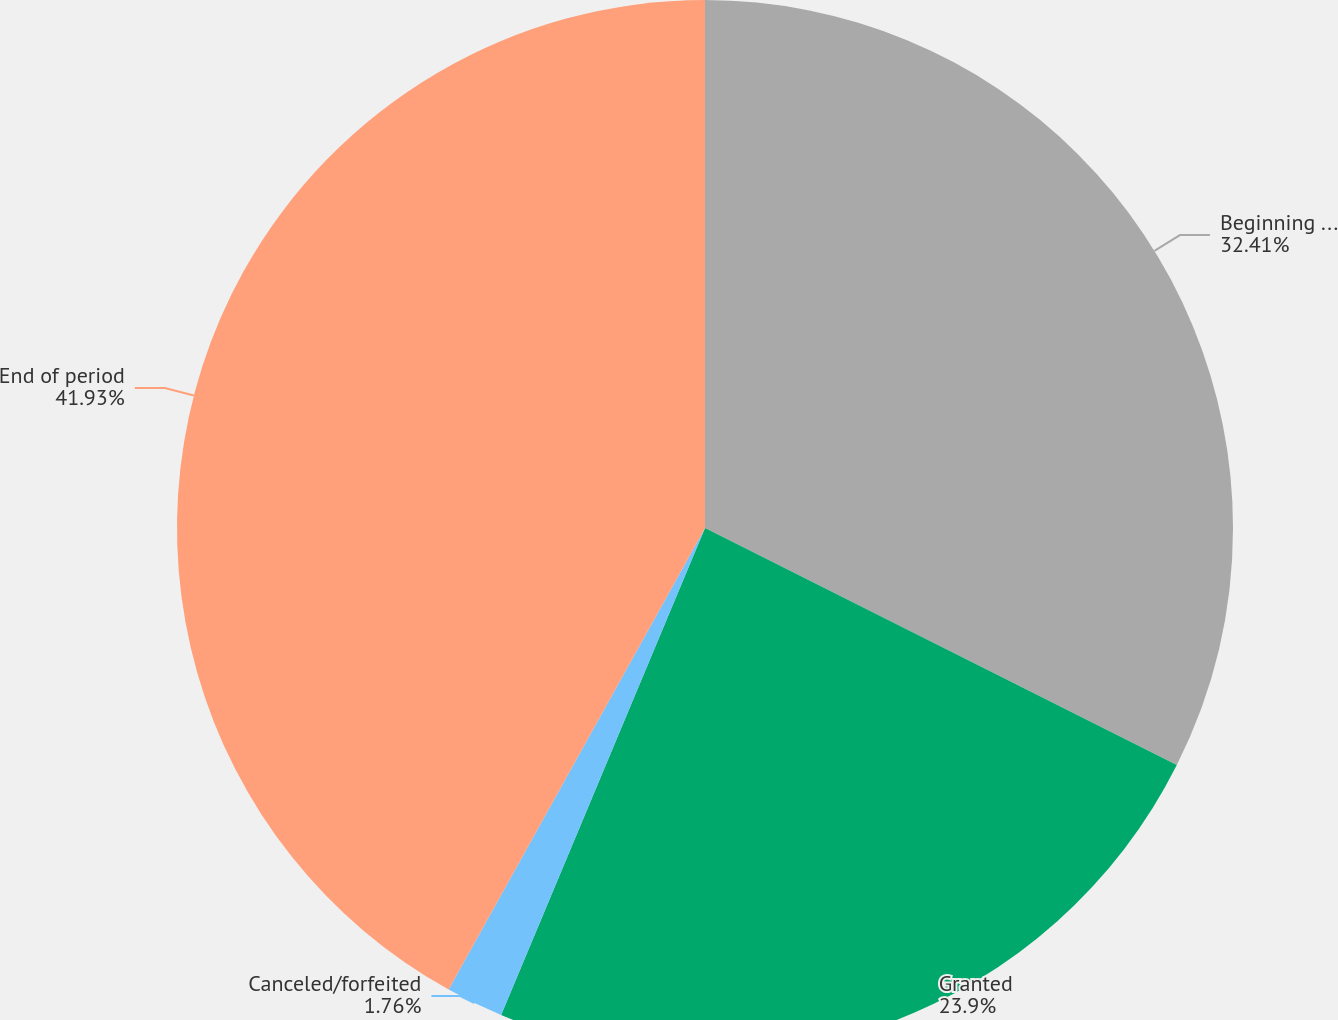Convert chart to OTSL. <chart><loc_0><loc_0><loc_500><loc_500><pie_chart><fcel>Beginning of year<fcel>Granted<fcel>Canceled/forfeited<fcel>End of period<nl><fcel>32.41%<fcel>23.9%<fcel>1.76%<fcel>41.93%<nl></chart> 